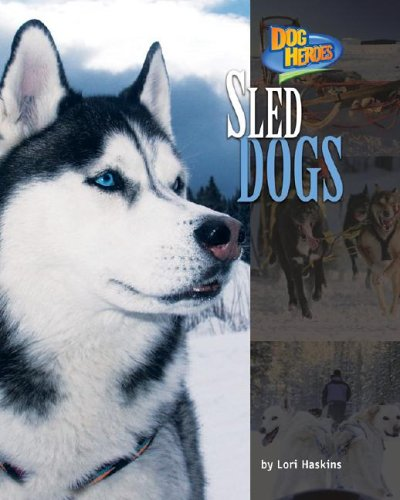Who is the author of this book? The book 'Sled Dogs (Dog Heroes)' is authored by Lori Haskins, known for writing children's literature. 